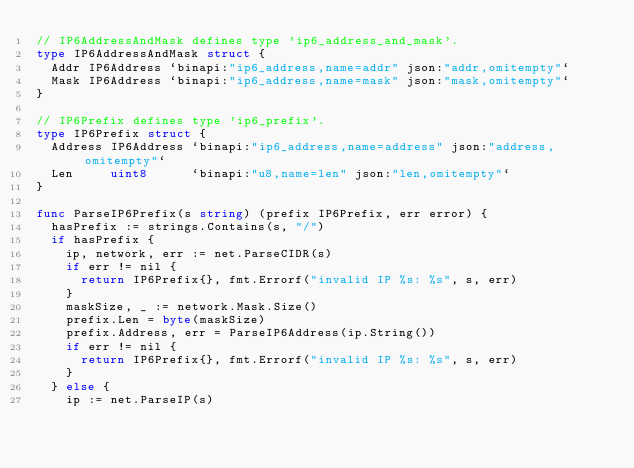Convert code to text. <code><loc_0><loc_0><loc_500><loc_500><_Go_>// IP6AddressAndMask defines type 'ip6_address_and_mask'.
type IP6AddressAndMask struct {
	Addr IP6Address `binapi:"ip6_address,name=addr" json:"addr,omitempty"`
	Mask IP6Address `binapi:"ip6_address,name=mask" json:"mask,omitempty"`
}

// IP6Prefix defines type 'ip6_prefix'.
type IP6Prefix struct {
	Address IP6Address `binapi:"ip6_address,name=address" json:"address,omitempty"`
	Len     uint8      `binapi:"u8,name=len" json:"len,omitempty"`
}

func ParseIP6Prefix(s string) (prefix IP6Prefix, err error) {
	hasPrefix := strings.Contains(s, "/")
	if hasPrefix {
		ip, network, err := net.ParseCIDR(s)
		if err != nil {
			return IP6Prefix{}, fmt.Errorf("invalid IP %s: %s", s, err)
		}
		maskSize, _ := network.Mask.Size()
		prefix.Len = byte(maskSize)
		prefix.Address, err = ParseIP6Address(ip.String())
		if err != nil {
			return IP6Prefix{}, fmt.Errorf("invalid IP %s: %s", s, err)
		}
	} else {
		ip := net.ParseIP(s)</code> 